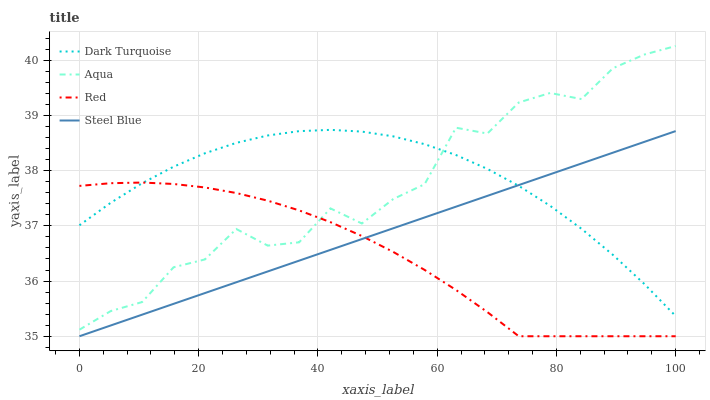Does Red have the minimum area under the curve?
Answer yes or no. Yes. Does Dark Turquoise have the maximum area under the curve?
Answer yes or no. Yes. Does Aqua have the minimum area under the curve?
Answer yes or no. No. Does Aqua have the maximum area under the curve?
Answer yes or no. No. Is Steel Blue the smoothest?
Answer yes or no. Yes. Is Aqua the roughest?
Answer yes or no. Yes. Is Aqua the smoothest?
Answer yes or no. No. Is Steel Blue the roughest?
Answer yes or no. No. Does Steel Blue have the lowest value?
Answer yes or no. Yes. Does Aqua have the lowest value?
Answer yes or no. No. Does Aqua have the highest value?
Answer yes or no. Yes. Does Steel Blue have the highest value?
Answer yes or no. No. Is Steel Blue less than Aqua?
Answer yes or no. Yes. Is Aqua greater than Steel Blue?
Answer yes or no. Yes. Does Red intersect Dark Turquoise?
Answer yes or no. Yes. Is Red less than Dark Turquoise?
Answer yes or no. No. Is Red greater than Dark Turquoise?
Answer yes or no. No. Does Steel Blue intersect Aqua?
Answer yes or no. No. 